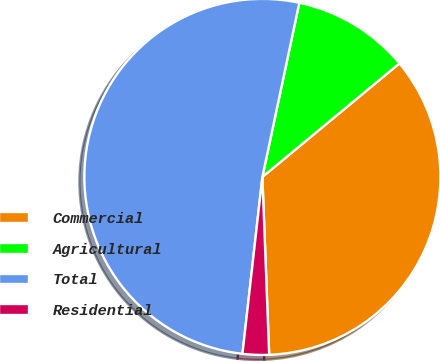Convert chart. <chart><loc_0><loc_0><loc_500><loc_500><pie_chart><fcel>Commercial<fcel>Agricultural<fcel>Total<fcel>Residential<nl><fcel>35.41%<fcel>10.66%<fcel>51.55%<fcel>2.39%<nl></chart> 